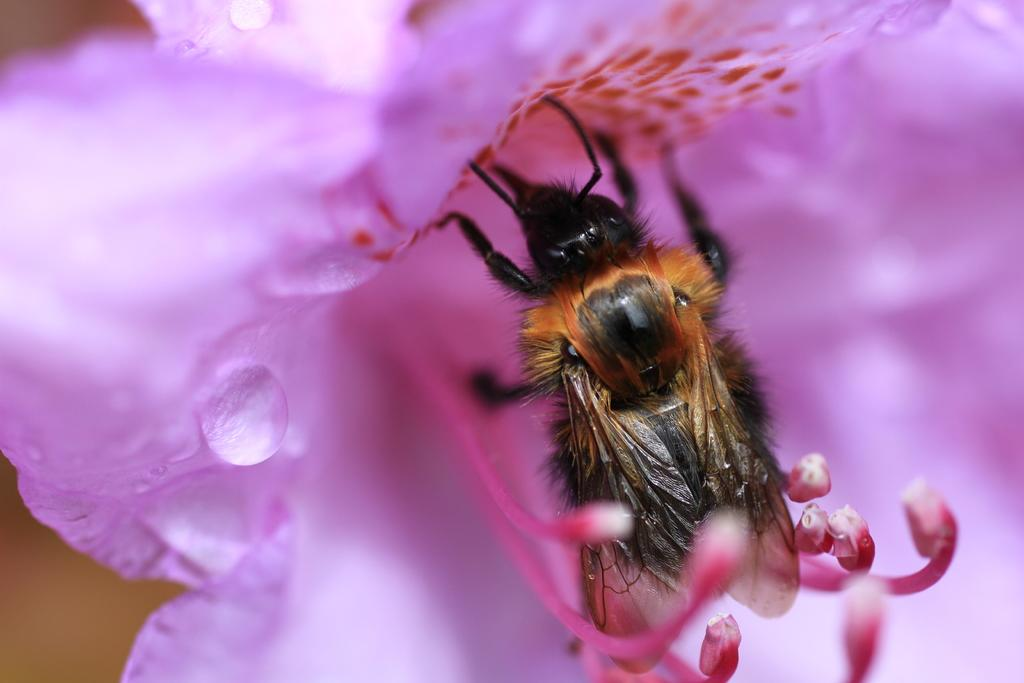What type of insect is present in the image? There is a honey bee in the image. Where is the honey bee located in the image? The honey bee is on a flower. What type of cast is visible on the honey bee in the image? There is no cast present on the honey bee in the image. How does the honey bee maintain its balance while flying in the image? The honey bee is not flying in the image; it is on a flower. 